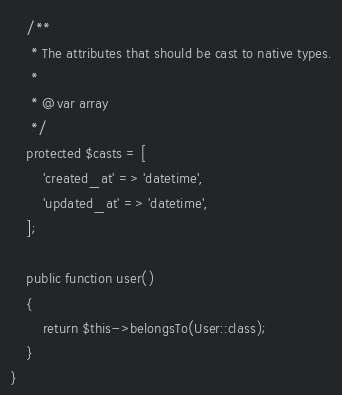<code> <loc_0><loc_0><loc_500><loc_500><_PHP_>
    /**
     * The attributes that should be cast to native types.
     *
     * @var array
     */
    protected $casts = [
        'created_at' => 'datetime',
        'updated_at' => 'datetime',
    ];

    public function user()
    {
        return $this->belongsTo(User::class);
    }
}
</code> 